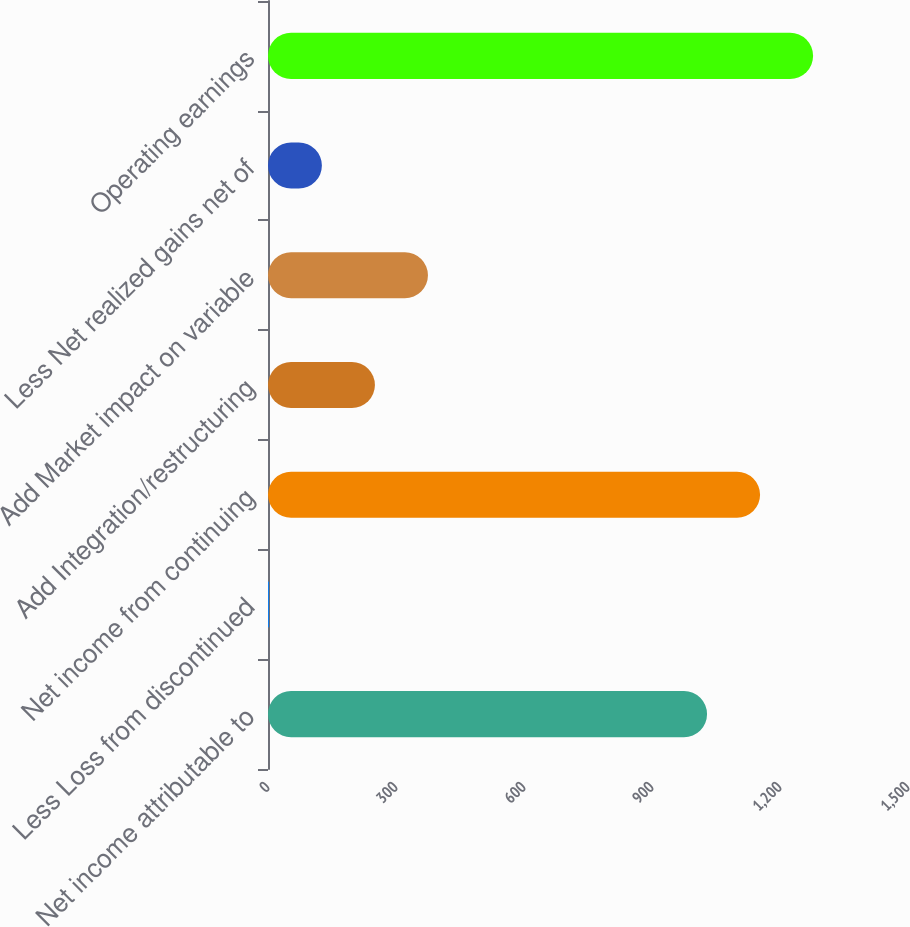Convert chart to OTSL. <chart><loc_0><loc_0><loc_500><loc_500><bar_chart><fcel>Net income attributable to<fcel>Less Loss from discontinued<fcel>Net income from continuing<fcel>Add Integration/restructuring<fcel>Add Market impact on variable<fcel>Less Net realized gains net of<fcel>Operating earnings<nl><fcel>1029<fcel>2<fcel>1153.3<fcel>250.6<fcel>374.9<fcel>126.3<fcel>1277.6<nl></chart> 